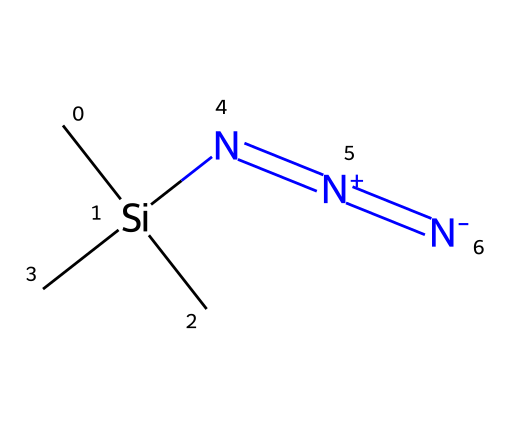How many nitrogen atoms are present in trimethylsilyl azide? The structure shows three nitrogen atoms as indicated by the three 'N' symbols in the SMILES representation.
Answer: three What is the central atom in the molecular structure? The central atom is the silicon atom, which is represented by 'Si' in the SMILES formula.
Answer: silicon How many methyl groups are attached to the silicon atom? The SMILES indicates there are three carbon groups ('C') attached to the silicon atom, which represent the three methyl groups.
Answer: three What type of chemical reaction is trimethylsilyl azide primarily used for? Trimethylsilyl azide is primarily used as a reagent for azide formation in organic synthesis reactions.
Answer: azide formation What is the charge on the terminal nitrogen atom in trimethylsilyl azide? The terminal nitrogen atom carries a negative charge as denoted by the '[N-]' in the SMILES representation.
Answer: negative Why is trimethylsilyl azide considered a good leaving group? Its structure allows for easy departure during reactions due to the formation of stable azides, making it a good leaving group in nucleophilic substitutions.
Answer: good leaving group What type of compound is trimethylsilyl azide categorized as? It is categorized as an azide compound due to the presence of the azide functional group -N3 in its structure.
Answer: azide 